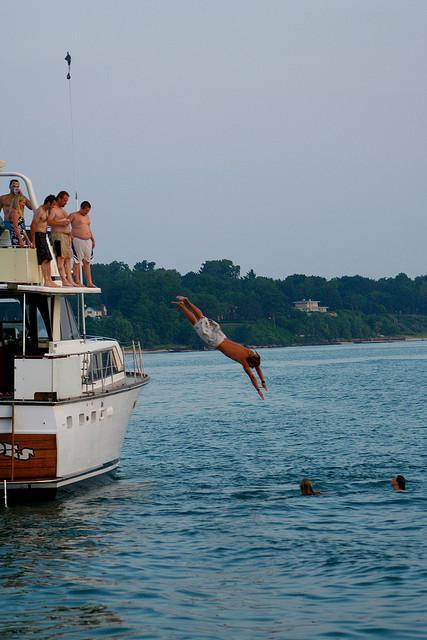How many people are in the water?
Give a very brief answer. 2. How many people are on the deck level of the boat?
Give a very brief answer. 4. How many people are on this boat?
Give a very brief answer. 5. How many people are in the boat?
Give a very brief answer. 4. 